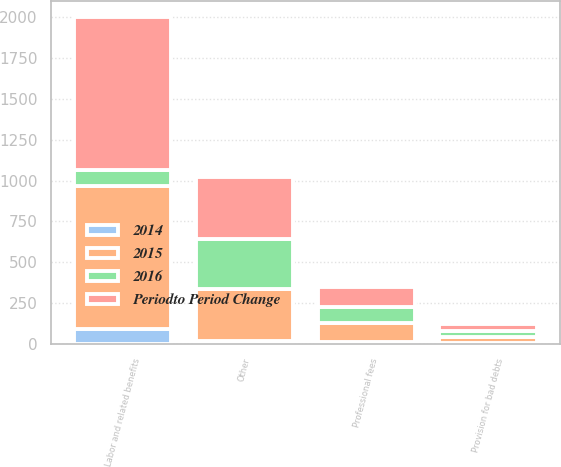Convert chart. <chart><loc_0><loc_0><loc_500><loc_500><stacked_bar_chart><ecel><fcel>Labor and related benefits<fcel>Professional fees<fcel>Provision for bad debts<fcel>Other<nl><fcel>2016<fcel>97<fcel>97<fcel>40<fcel>305<nl><fcel>2014<fcel>94<fcel>15<fcel>4<fcel>16<nl><fcel>2015<fcel>874<fcel>112<fcel>36<fcel>321<nl><fcel>Periodto Period Change<fcel>933<fcel>126<fcel>41<fcel>381<nl></chart> 